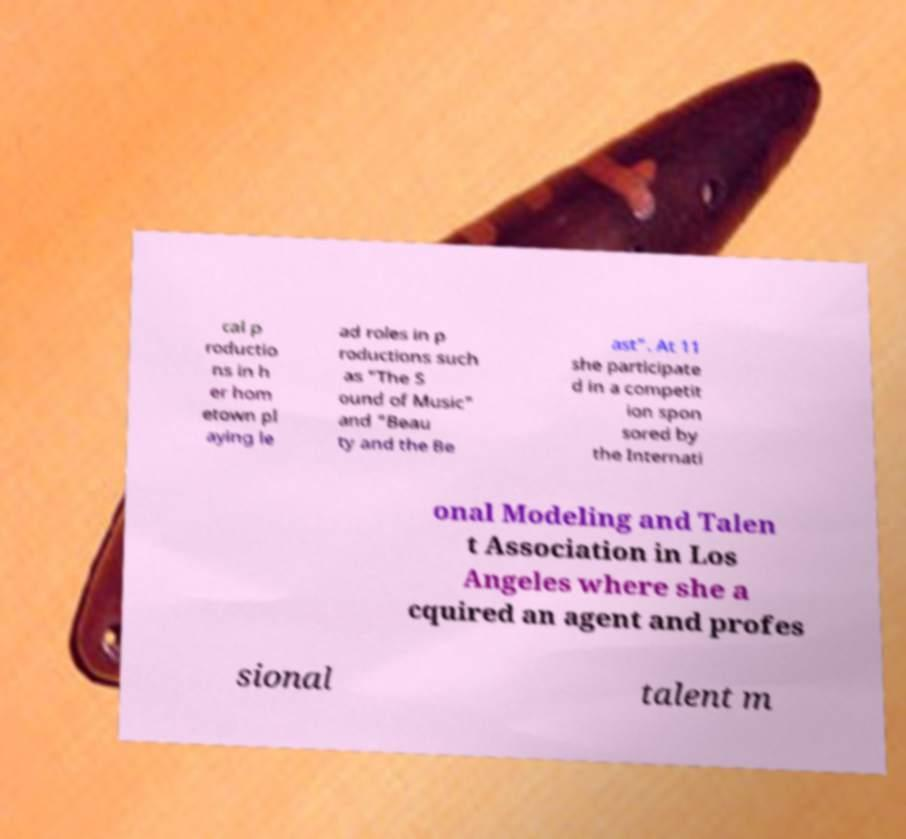Could you extract and type out the text from this image? cal p roductio ns in h er hom etown pl aying le ad roles in p roductions such as "The S ound of Music" and "Beau ty and the Be ast". At 11 she participate d in a competit ion spon sored by the Internati onal Modeling and Talen t Association in Los Angeles where she a cquired an agent and profes sional talent m 